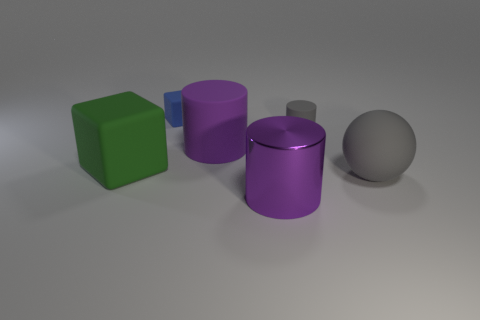How many matte cylinders have the same color as the large metallic cylinder?
Your response must be concise. 1. Are there an equal number of small gray things that are in front of the small cylinder and gray matte cubes?
Your answer should be compact. Yes. Are there any other things that have the same shape as the blue matte thing?
Make the answer very short. Yes. There is a small blue matte object; does it have the same shape as the large thing on the left side of the purple rubber object?
Offer a terse response. Yes. What size is the purple matte object that is the same shape as the large shiny thing?
Ensure brevity in your answer.  Large. What is the big block made of?
Ensure brevity in your answer.  Rubber. Is the color of the metal object that is in front of the large purple rubber object the same as the big cylinder behind the green matte object?
Offer a very short reply. Yes. Are there more green rubber things in front of the tiny gray thing than tiny cyan cylinders?
Provide a succinct answer. Yes. What number of other things are there of the same color as the rubber sphere?
Offer a very short reply. 1. There is a purple thing that is behind the matte ball; is it the same size as the purple shiny thing?
Your response must be concise. Yes. 